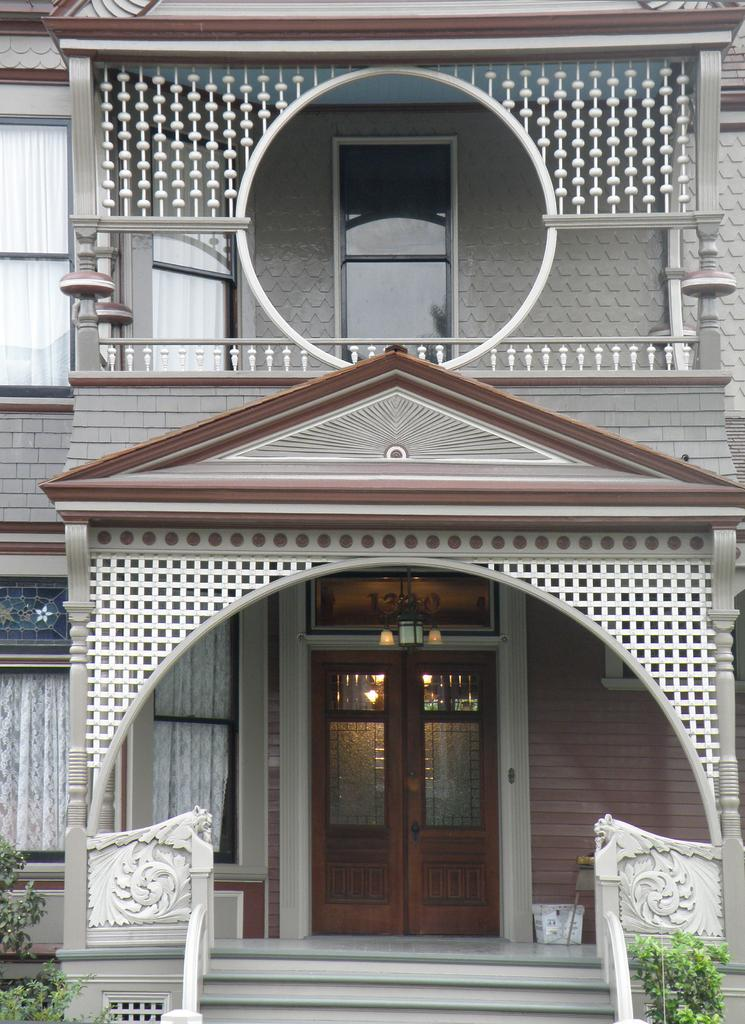What is the main subject in the foreground of the image? There is a building in the foreground of the image. What features can be seen on the building? The building has a door, windows, and stairs. Are there any natural elements near the building? Yes, there are plants near the building. What can be found inside the building? There are curtains in the building. What flavor of crow can be seen perched on the door in the image? There are no crows present in the image, and therefore no flavor can be determined. 